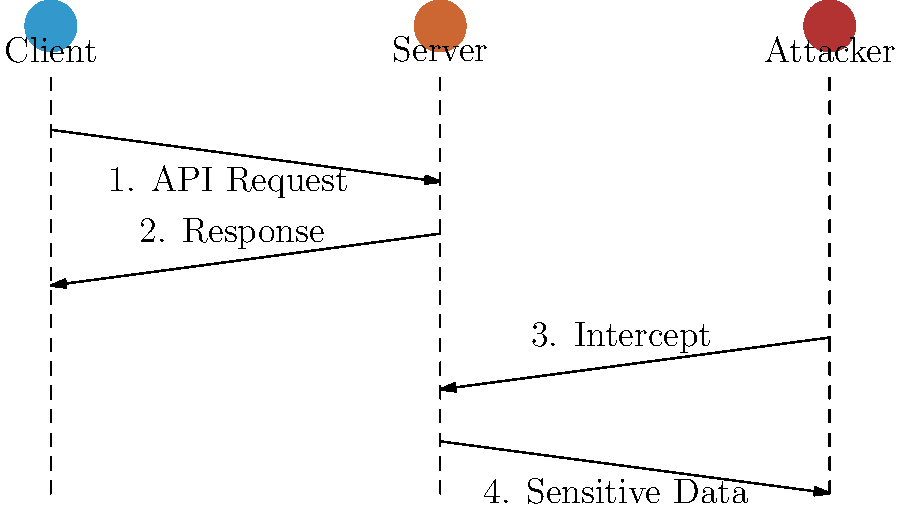In the sequence diagram, which security measure should be implemented to prevent the attacker from intercepting sensitive data in step 4? To prevent the attacker from intercepting sensitive data in step 4 of the sequence diagram, we need to implement proper API endpoint security measures. Here's a step-by-step explanation:

1. Identify the vulnerability: The diagram shows that the attacker can intercept the communication between the server and the client, potentially accessing sensitive data.

2. Understand the attack vector: The attacker is able to intercept the data in transit, which suggests a lack of encryption or secure communication protocol.

3. Determine the security measure: To protect against this type of attack, we need to implement end-to-end encryption for all API communications.

4. Implement the solution: Use HTTPS (HTTP over TLS/SSL) for all API endpoints. This ensures that all data transmitted between the client and server is encrypted.

5. Additional measures:
   a. Implement proper authentication mechanisms (e.g., OAuth 2.0, JWT)
   b. Use API keys or access tokens to control access to the API
   c. Implement rate limiting to prevent abuse
   d. Regularly update and patch the server software

6. Verify the solution: After implementing HTTPS, the attacker would only be able to see encrypted data, rendering the interception useless.

By implementing HTTPS, we ensure that all communications between the client and server are encrypted, preventing the attacker from accessing sensitive data even if they manage to intercept the traffic.
Answer: HTTPS (TLS/SSL encryption) 